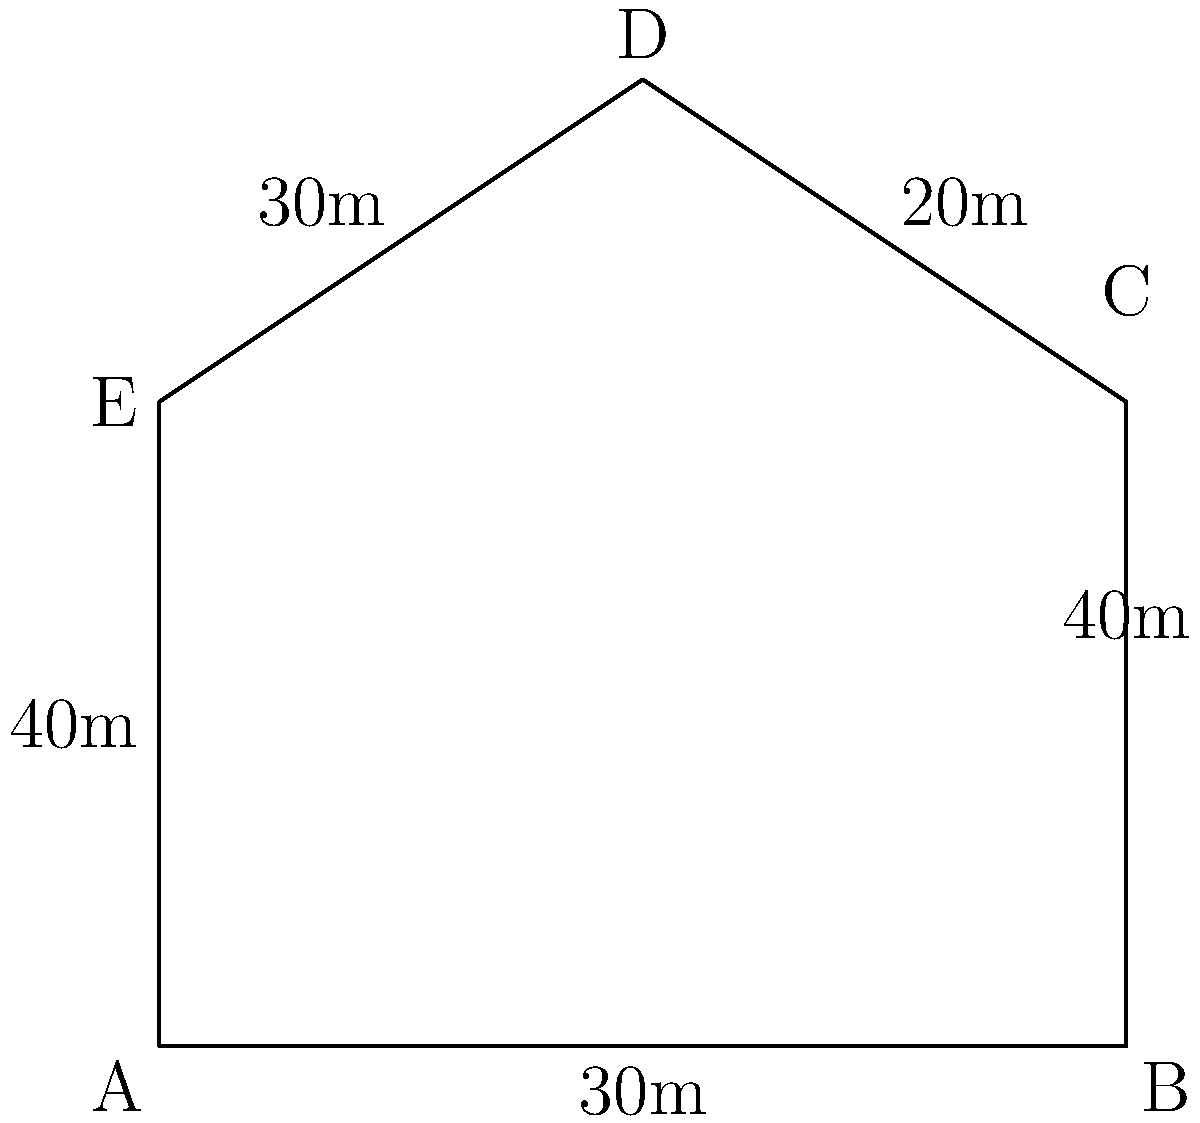As a tour guide specializing in Hitchcock film locations, you're explaining the bird's-eye view of the famous Bodega Bay schoolhouse from "The Birds." The aerial outline of the location forms an irregular pentagon, as shown in the diagram. If the measurements of each side are as indicated (in meters), what is the total area of the schoolhouse grounds in square meters? To find the area of this irregular pentagon, we can divide it into simpler shapes and sum their areas. Let's break it down step-by-step:

1) First, let's divide the pentagon into a rectangle (ABCE) and a triangle (CDE).

2) For the rectangle ABCE:
   - Width = 6m (side AB)
   - Height = 4m (side AE)
   - Area of rectangle = $6 \times 4 = 24$ sq meters

3) For the triangle CDE:
   - Base = 6m (side CE)
   - Height = We need to calculate this
   
4) To find the height of the triangle:
   - The triangle's base is 6m, and its hypotenuse (CD) is 20m
   - Let the height be h
   - Using the Pythagorean theorem: $6^2 + h^2 = 20^2$
   - $36 + h^2 = 400$
   - $h^2 = 364$
   - $h = \sqrt{364} = 2\sqrt{91} \approx 19.08$ meters

5) Now we can calculate the area of the triangle:
   Area of triangle = $\frac{1}{2} \times base \times height$
                    = $\frac{1}{2} \times 6 \times 2\sqrt{91}$
                    = $6\sqrt{91}$ sq meters

6) Total area = Area of rectangle + Area of triangle
              = $24 + 6\sqrt{91}$ sq meters

Therefore, the total area of the schoolhouse grounds is $24 + 6\sqrt{91}$ square meters.
Answer: $24 + 6\sqrt{91}$ sq meters 